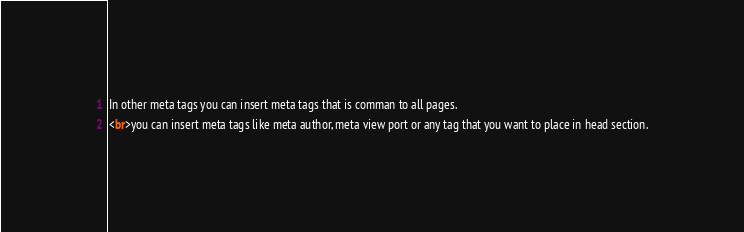<code> <loc_0><loc_0><loc_500><loc_500><_HTML_>In other meta tags you can insert meta tags that is comman to all pages.
<br>you can insert meta tags like meta author, meta view port or any tag that you want to place in head section.</code> 